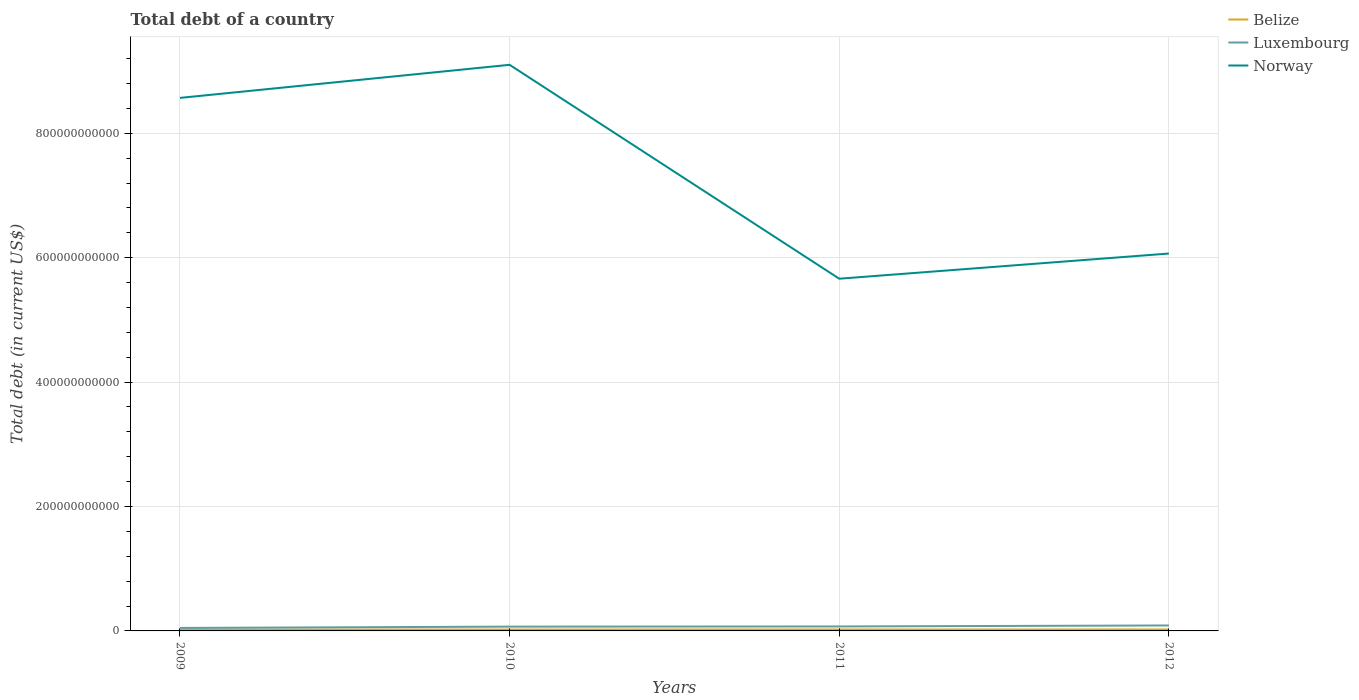How many different coloured lines are there?
Offer a terse response. 3. Does the line corresponding to Norway intersect with the line corresponding to Belize?
Make the answer very short. No. Is the number of lines equal to the number of legend labels?
Keep it short and to the point. Yes. Across all years, what is the maximum debt in Luxembourg?
Provide a succinct answer. 4.80e+09. What is the total debt in Belize in the graph?
Your answer should be very brief. -9.35e+07. What is the difference between the highest and the second highest debt in Norway?
Provide a short and direct response. 3.44e+11. What is the difference between the highest and the lowest debt in Luxembourg?
Offer a terse response. 2. Is the debt in Norway strictly greater than the debt in Belize over the years?
Offer a terse response. No. How many lines are there?
Offer a very short reply. 3. How many years are there in the graph?
Ensure brevity in your answer.  4. What is the difference between two consecutive major ticks on the Y-axis?
Your answer should be compact. 2.00e+11. Where does the legend appear in the graph?
Your answer should be compact. Top right. How many legend labels are there?
Provide a short and direct response. 3. How are the legend labels stacked?
Your answer should be very brief. Vertical. What is the title of the graph?
Make the answer very short. Total debt of a country. What is the label or title of the Y-axis?
Keep it short and to the point. Total debt (in current US$). What is the Total debt (in current US$) in Belize in 2009?
Provide a succinct answer. 2.19e+09. What is the Total debt (in current US$) in Luxembourg in 2009?
Your answer should be very brief. 4.80e+09. What is the Total debt (in current US$) in Norway in 2009?
Your answer should be compact. 8.57e+11. What is the Total debt (in current US$) in Belize in 2010?
Offer a very short reply. 2.24e+09. What is the Total debt (in current US$) of Luxembourg in 2010?
Provide a succinct answer. 6.89e+09. What is the Total debt (in current US$) of Norway in 2010?
Give a very brief answer. 9.10e+11. What is the Total debt (in current US$) of Belize in 2011?
Your response must be concise. 2.29e+09. What is the Total debt (in current US$) of Luxembourg in 2011?
Provide a succinct answer. 7.18e+09. What is the Total debt (in current US$) in Norway in 2011?
Provide a succinct answer. 5.66e+11. What is the Total debt (in current US$) in Belize in 2012?
Keep it short and to the point. 2.34e+09. What is the Total debt (in current US$) in Luxembourg in 2012?
Your answer should be very brief. 8.78e+09. What is the Total debt (in current US$) in Norway in 2012?
Provide a short and direct response. 6.07e+11. Across all years, what is the maximum Total debt (in current US$) in Belize?
Offer a very short reply. 2.34e+09. Across all years, what is the maximum Total debt (in current US$) in Luxembourg?
Make the answer very short. 8.78e+09. Across all years, what is the maximum Total debt (in current US$) in Norway?
Provide a succinct answer. 9.10e+11. Across all years, what is the minimum Total debt (in current US$) in Belize?
Ensure brevity in your answer.  2.19e+09. Across all years, what is the minimum Total debt (in current US$) in Luxembourg?
Offer a terse response. 4.80e+09. Across all years, what is the minimum Total debt (in current US$) of Norway?
Keep it short and to the point. 5.66e+11. What is the total Total debt (in current US$) in Belize in the graph?
Keep it short and to the point. 9.06e+09. What is the total Total debt (in current US$) in Luxembourg in the graph?
Provide a succinct answer. 2.76e+1. What is the total Total debt (in current US$) of Norway in the graph?
Keep it short and to the point. 2.94e+12. What is the difference between the Total debt (in current US$) in Belize in 2009 and that in 2010?
Provide a succinct answer. -4.73e+07. What is the difference between the Total debt (in current US$) in Luxembourg in 2009 and that in 2010?
Offer a terse response. -2.10e+09. What is the difference between the Total debt (in current US$) of Norway in 2009 and that in 2010?
Offer a very short reply. -5.32e+1. What is the difference between the Total debt (in current US$) of Belize in 2009 and that in 2011?
Offer a very short reply. -9.35e+07. What is the difference between the Total debt (in current US$) of Luxembourg in 2009 and that in 2011?
Give a very brief answer. -2.38e+09. What is the difference between the Total debt (in current US$) of Norway in 2009 and that in 2011?
Ensure brevity in your answer.  2.91e+11. What is the difference between the Total debt (in current US$) of Belize in 2009 and that in 2012?
Provide a short and direct response. -1.51e+08. What is the difference between the Total debt (in current US$) of Luxembourg in 2009 and that in 2012?
Your response must be concise. -3.98e+09. What is the difference between the Total debt (in current US$) in Norway in 2009 and that in 2012?
Your answer should be compact. 2.50e+11. What is the difference between the Total debt (in current US$) of Belize in 2010 and that in 2011?
Make the answer very short. -4.62e+07. What is the difference between the Total debt (in current US$) of Luxembourg in 2010 and that in 2011?
Offer a terse response. -2.83e+08. What is the difference between the Total debt (in current US$) in Norway in 2010 and that in 2011?
Make the answer very short. 3.44e+11. What is the difference between the Total debt (in current US$) of Belize in 2010 and that in 2012?
Give a very brief answer. -1.04e+08. What is the difference between the Total debt (in current US$) of Luxembourg in 2010 and that in 2012?
Make the answer very short. -1.88e+09. What is the difference between the Total debt (in current US$) of Norway in 2010 and that in 2012?
Keep it short and to the point. 3.03e+11. What is the difference between the Total debt (in current US$) of Belize in 2011 and that in 2012?
Keep it short and to the point. -5.79e+07. What is the difference between the Total debt (in current US$) of Luxembourg in 2011 and that in 2012?
Provide a short and direct response. -1.60e+09. What is the difference between the Total debt (in current US$) in Norway in 2011 and that in 2012?
Your response must be concise. -4.05e+1. What is the difference between the Total debt (in current US$) in Belize in 2009 and the Total debt (in current US$) in Luxembourg in 2010?
Keep it short and to the point. -4.70e+09. What is the difference between the Total debt (in current US$) in Belize in 2009 and the Total debt (in current US$) in Norway in 2010?
Your answer should be compact. -9.08e+11. What is the difference between the Total debt (in current US$) in Luxembourg in 2009 and the Total debt (in current US$) in Norway in 2010?
Your answer should be compact. -9.05e+11. What is the difference between the Total debt (in current US$) in Belize in 2009 and the Total debt (in current US$) in Luxembourg in 2011?
Your answer should be compact. -4.98e+09. What is the difference between the Total debt (in current US$) of Belize in 2009 and the Total debt (in current US$) of Norway in 2011?
Offer a very short reply. -5.64e+11. What is the difference between the Total debt (in current US$) of Luxembourg in 2009 and the Total debt (in current US$) of Norway in 2011?
Provide a short and direct response. -5.61e+11. What is the difference between the Total debt (in current US$) in Belize in 2009 and the Total debt (in current US$) in Luxembourg in 2012?
Keep it short and to the point. -6.59e+09. What is the difference between the Total debt (in current US$) in Belize in 2009 and the Total debt (in current US$) in Norway in 2012?
Provide a succinct answer. -6.05e+11. What is the difference between the Total debt (in current US$) in Luxembourg in 2009 and the Total debt (in current US$) in Norway in 2012?
Ensure brevity in your answer.  -6.02e+11. What is the difference between the Total debt (in current US$) in Belize in 2010 and the Total debt (in current US$) in Luxembourg in 2011?
Your answer should be very brief. -4.94e+09. What is the difference between the Total debt (in current US$) of Belize in 2010 and the Total debt (in current US$) of Norway in 2011?
Offer a terse response. -5.64e+11. What is the difference between the Total debt (in current US$) of Luxembourg in 2010 and the Total debt (in current US$) of Norway in 2011?
Provide a succinct answer. -5.59e+11. What is the difference between the Total debt (in current US$) of Belize in 2010 and the Total debt (in current US$) of Luxembourg in 2012?
Keep it short and to the point. -6.54e+09. What is the difference between the Total debt (in current US$) in Belize in 2010 and the Total debt (in current US$) in Norway in 2012?
Offer a very short reply. -6.04e+11. What is the difference between the Total debt (in current US$) of Luxembourg in 2010 and the Total debt (in current US$) of Norway in 2012?
Provide a succinct answer. -6.00e+11. What is the difference between the Total debt (in current US$) in Belize in 2011 and the Total debt (in current US$) in Luxembourg in 2012?
Give a very brief answer. -6.49e+09. What is the difference between the Total debt (in current US$) in Belize in 2011 and the Total debt (in current US$) in Norway in 2012?
Your answer should be very brief. -6.04e+11. What is the difference between the Total debt (in current US$) of Luxembourg in 2011 and the Total debt (in current US$) of Norway in 2012?
Your response must be concise. -6.00e+11. What is the average Total debt (in current US$) in Belize per year?
Provide a succinct answer. 2.27e+09. What is the average Total debt (in current US$) in Luxembourg per year?
Your answer should be compact. 6.91e+09. What is the average Total debt (in current US$) in Norway per year?
Provide a succinct answer. 7.35e+11. In the year 2009, what is the difference between the Total debt (in current US$) of Belize and Total debt (in current US$) of Luxembourg?
Give a very brief answer. -2.61e+09. In the year 2009, what is the difference between the Total debt (in current US$) in Belize and Total debt (in current US$) in Norway?
Give a very brief answer. -8.55e+11. In the year 2009, what is the difference between the Total debt (in current US$) in Luxembourg and Total debt (in current US$) in Norway?
Provide a succinct answer. -8.52e+11. In the year 2010, what is the difference between the Total debt (in current US$) in Belize and Total debt (in current US$) in Luxembourg?
Offer a very short reply. -4.65e+09. In the year 2010, what is the difference between the Total debt (in current US$) in Belize and Total debt (in current US$) in Norway?
Make the answer very short. -9.08e+11. In the year 2010, what is the difference between the Total debt (in current US$) in Luxembourg and Total debt (in current US$) in Norway?
Offer a terse response. -9.03e+11. In the year 2011, what is the difference between the Total debt (in current US$) in Belize and Total debt (in current US$) in Luxembourg?
Your response must be concise. -4.89e+09. In the year 2011, what is the difference between the Total debt (in current US$) of Belize and Total debt (in current US$) of Norway?
Make the answer very short. -5.64e+11. In the year 2011, what is the difference between the Total debt (in current US$) of Luxembourg and Total debt (in current US$) of Norway?
Keep it short and to the point. -5.59e+11. In the year 2012, what is the difference between the Total debt (in current US$) in Belize and Total debt (in current US$) in Luxembourg?
Your answer should be compact. -6.43e+09. In the year 2012, what is the difference between the Total debt (in current US$) in Belize and Total debt (in current US$) in Norway?
Keep it short and to the point. -6.04e+11. In the year 2012, what is the difference between the Total debt (in current US$) in Luxembourg and Total debt (in current US$) in Norway?
Your answer should be very brief. -5.98e+11. What is the ratio of the Total debt (in current US$) in Belize in 2009 to that in 2010?
Give a very brief answer. 0.98. What is the ratio of the Total debt (in current US$) in Luxembourg in 2009 to that in 2010?
Keep it short and to the point. 0.7. What is the ratio of the Total debt (in current US$) of Norway in 2009 to that in 2010?
Make the answer very short. 0.94. What is the ratio of the Total debt (in current US$) in Belize in 2009 to that in 2011?
Provide a succinct answer. 0.96. What is the ratio of the Total debt (in current US$) of Luxembourg in 2009 to that in 2011?
Make the answer very short. 0.67. What is the ratio of the Total debt (in current US$) in Norway in 2009 to that in 2011?
Make the answer very short. 1.51. What is the ratio of the Total debt (in current US$) of Belize in 2009 to that in 2012?
Keep it short and to the point. 0.94. What is the ratio of the Total debt (in current US$) of Luxembourg in 2009 to that in 2012?
Offer a very short reply. 0.55. What is the ratio of the Total debt (in current US$) in Norway in 2009 to that in 2012?
Your answer should be compact. 1.41. What is the ratio of the Total debt (in current US$) of Belize in 2010 to that in 2011?
Offer a terse response. 0.98. What is the ratio of the Total debt (in current US$) in Luxembourg in 2010 to that in 2011?
Your answer should be very brief. 0.96. What is the ratio of the Total debt (in current US$) of Norway in 2010 to that in 2011?
Keep it short and to the point. 1.61. What is the ratio of the Total debt (in current US$) of Belize in 2010 to that in 2012?
Provide a short and direct response. 0.96. What is the ratio of the Total debt (in current US$) of Luxembourg in 2010 to that in 2012?
Offer a very short reply. 0.79. What is the ratio of the Total debt (in current US$) of Norway in 2010 to that in 2012?
Give a very brief answer. 1.5. What is the ratio of the Total debt (in current US$) in Belize in 2011 to that in 2012?
Your answer should be compact. 0.98. What is the ratio of the Total debt (in current US$) of Luxembourg in 2011 to that in 2012?
Provide a succinct answer. 0.82. What is the ratio of the Total debt (in current US$) in Norway in 2011 to that in 2012?
Provide a succinct answer. 0.93. What is the difference between the highest and the second highest Total debt (in current US$) of Belize?
Your answer should be very brief. 5.79e+07. What is the difference between the highest and the second highest Total debt (in current US$) of Luxembourg?
Your answer should be compact. 1.60e+09. What is the difference between the highest and the second highest Total debt (in current US$) of Norway?
Your response must be concise. 5.32e+1. What is the difference between the highest and the lowest Total debt (in current US$) of Belize?
Give a very brief answer. 1.51e+08. What is the difference between the highest and the lowest Total debt (in current US$) of Luxembourg?
Offer a very short reply. 3.98e+09. What is the difference between the highest and the lowest Total debt (in current US$) in Norway?
Give a very brief answer. 3.44e+11. 